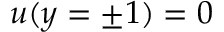<formula> <loc_0><loc_0><loc_500><loc_500>u ( y = \pm 1 ) = 0</formula> 